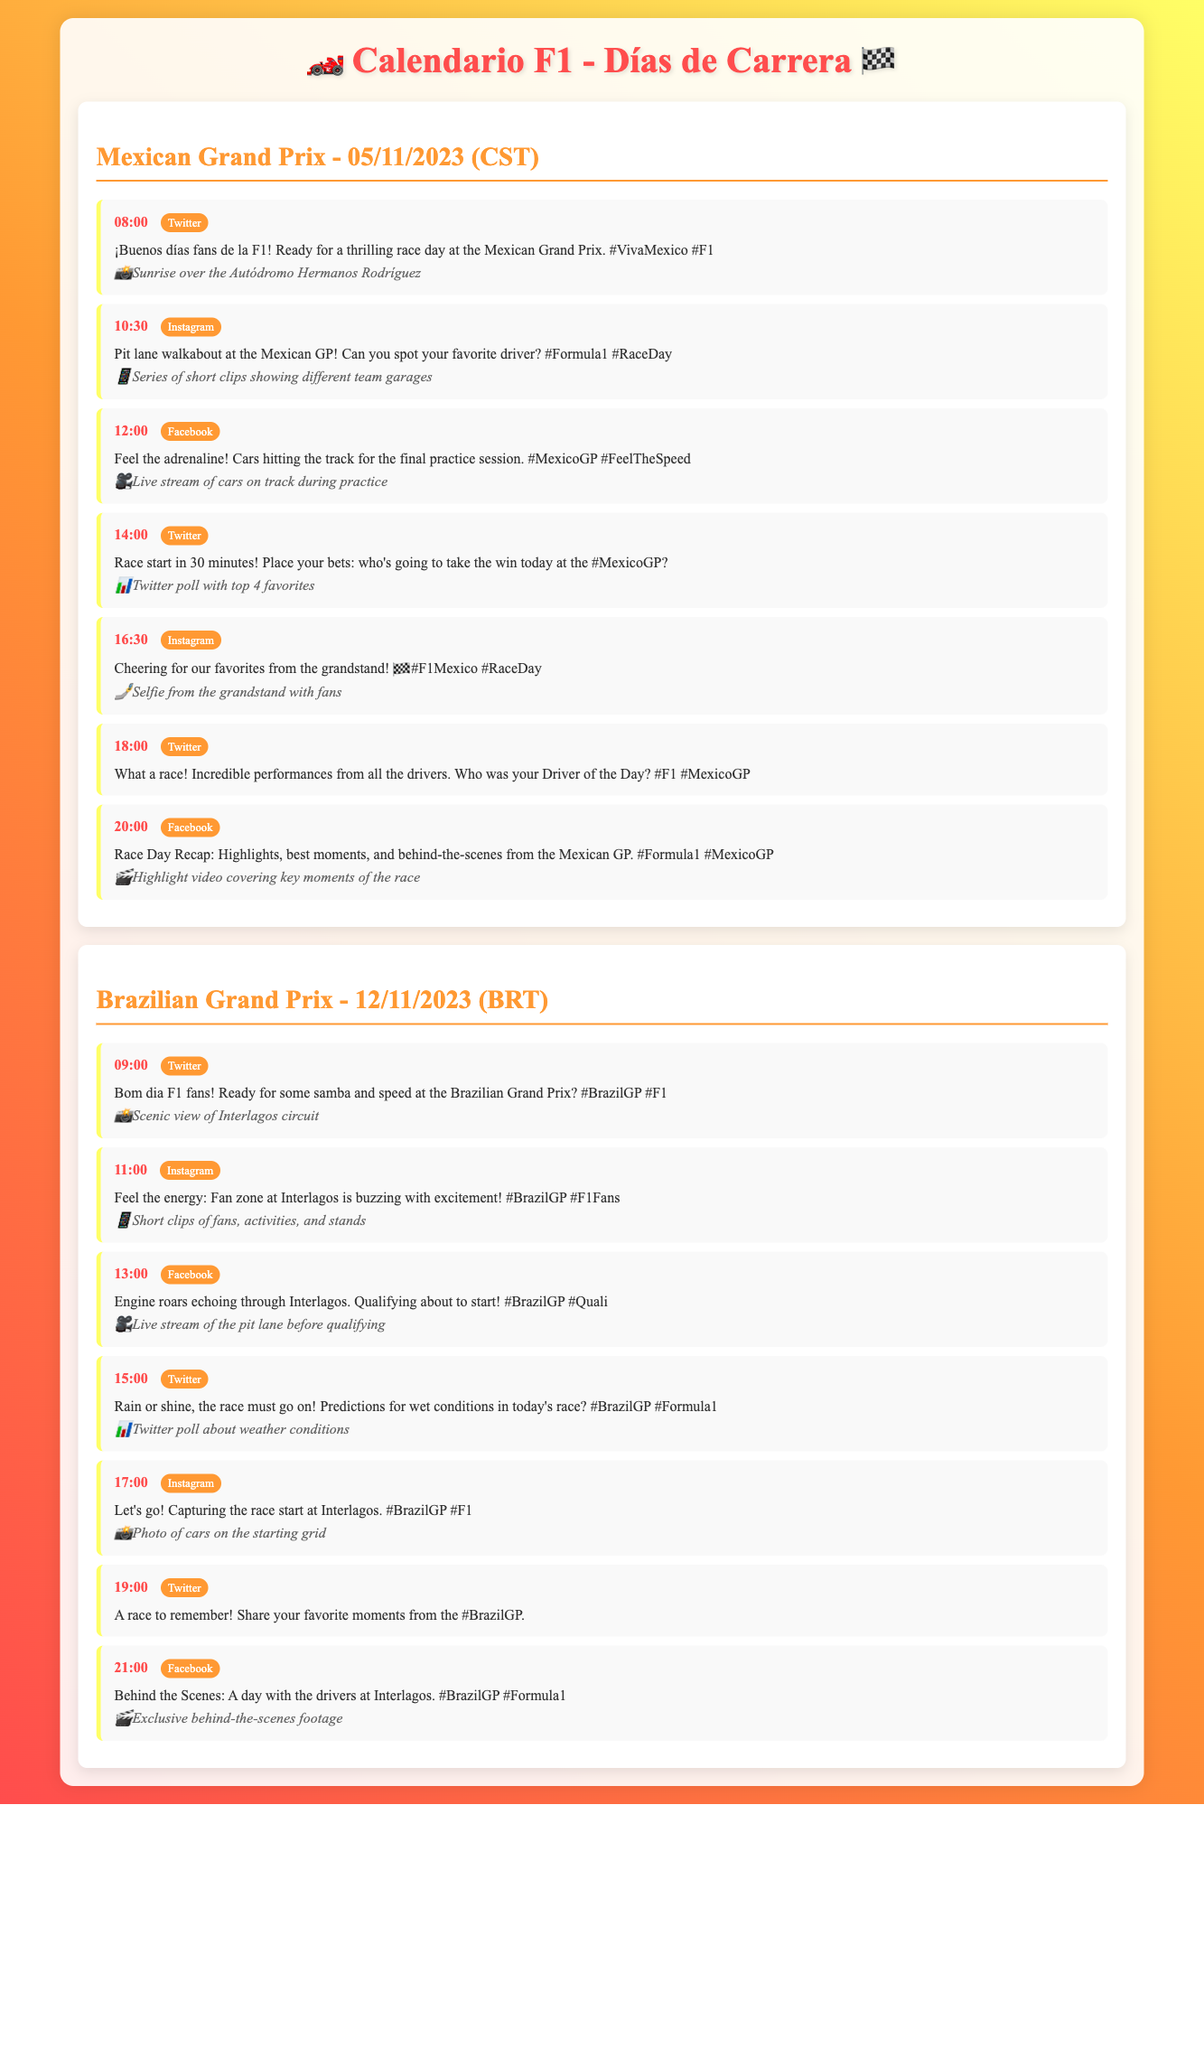¿Qué día se celebra el Gran Premio de México? El Gran Premio de México se celebra el 5 de noviembre de 2023.
Answer: 05/11/2023 ¿Cuál es la primera publicación programada para el Gran Premio de Brasil? La primera publicación programada para el Gran Premio de Brasil es a las 09:00 en Twitter.
Answer: 09:00 ¿Cuántas publicaciones se hacen en Twitter durante el Gran Premio de México? Hay cuatro publicaciones programadas en Twitter durante el Gran Premio de México.
Answer: Cuatro ¿Qué plataforma se utiliza para compartir la transmisión en vivo de la sesión de práctica final? La plataforma utilizada para compartir la transmisión en vivo de la sesión de práctica final es Facebook.
Answer: Facebook ¿Cuál es el contenido de la publicación a las 16:30 del Gran Premio de México? La publicación a las 16:30 es sobre animar a los favoritos desde las gradas.
Answer: Cheering for our favorites from the grandstand! ¿Qué tipo de contenido se publica a las 21:00 del Gran Premio de Brasil? A las 21:00 se publica contenido detrás de las escenas de los conductores.
Answer: Behind the Scenes ¿Qué momento del día es clave para la clasificación en el Gran Premio de Brasil? El momento clave para la clasificación es a la 1:00.
Answer: 13:00 